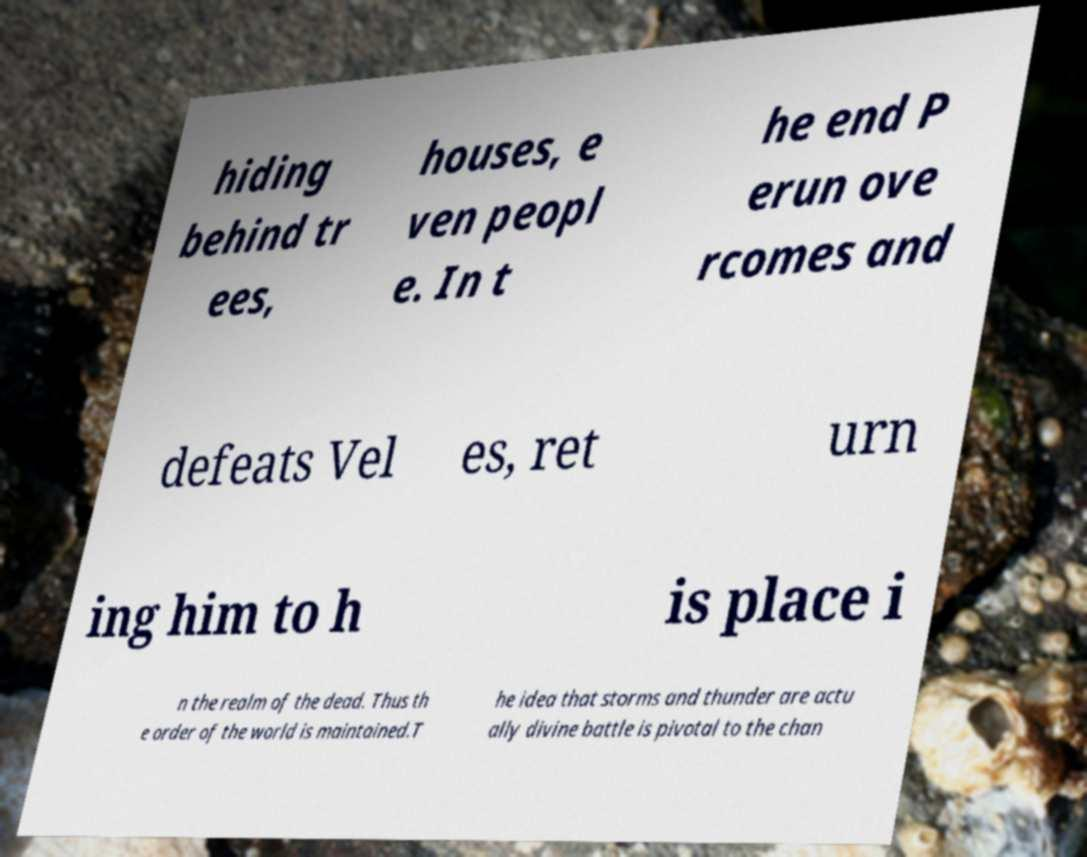Please read and relay the text visible in this image. What does it say? hiding behind tr ees, houses, e ven peopl e. In t he end P erun ove rcomes and defeats Vel es, ret urn ing him to h is place i n the realm of the dead. Thus th e order of the world is maintained.T he idea that storms and thunder are actu ally divine battle is pivotal to the chan 